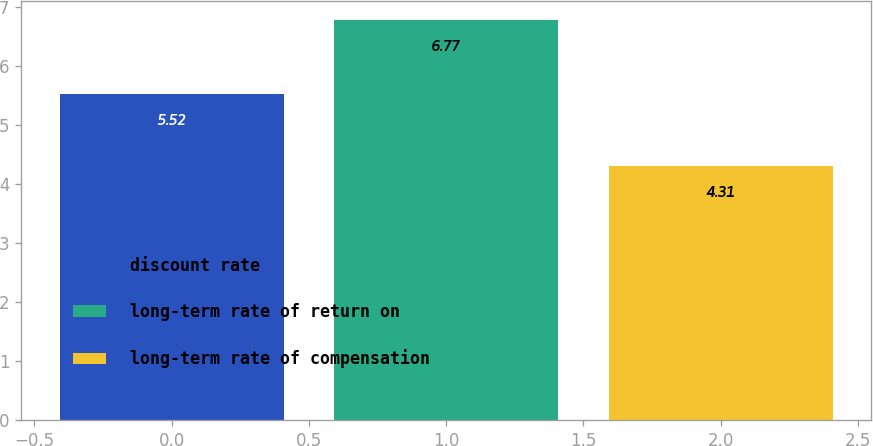Convert chart. <chart><loc_0><loc_0><loc_500><loc_500><bar_chart><fcel>discount rate<fcel>long-term rate of return on<fcel>long-term rate of compensation<nl><fcel>5.52<fcel>6.77<fcel>4.31<nl></chart> 